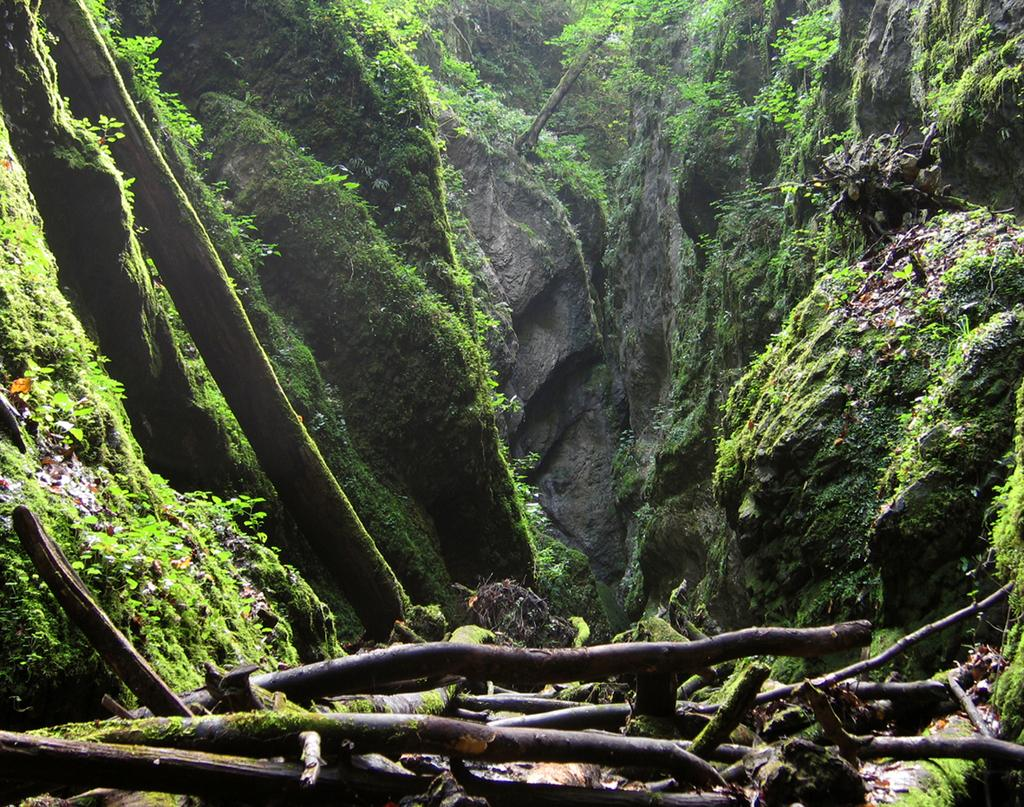What type of objects can be seen in the image that are made of wood? There are wooden objects in the image. What type of living organisms can be seen in the image? There are plants and algae present in the image. What type of natural formation can be seen in the image? There are rocks in the image. How many sheep are visible in the image? There are no sheep present in the image. What type of brick is used to build the structure in the image? There is no structure or brick present in the image. 